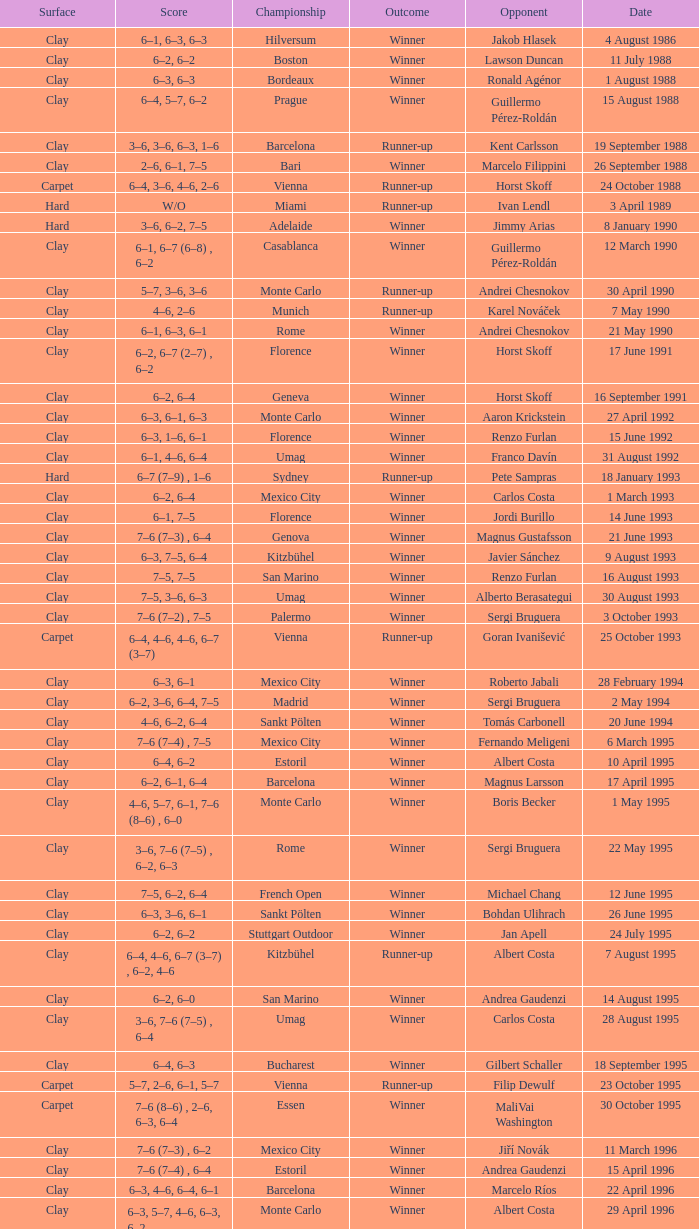Who is the opponent on 18 january 1993? Pete Sampras. 